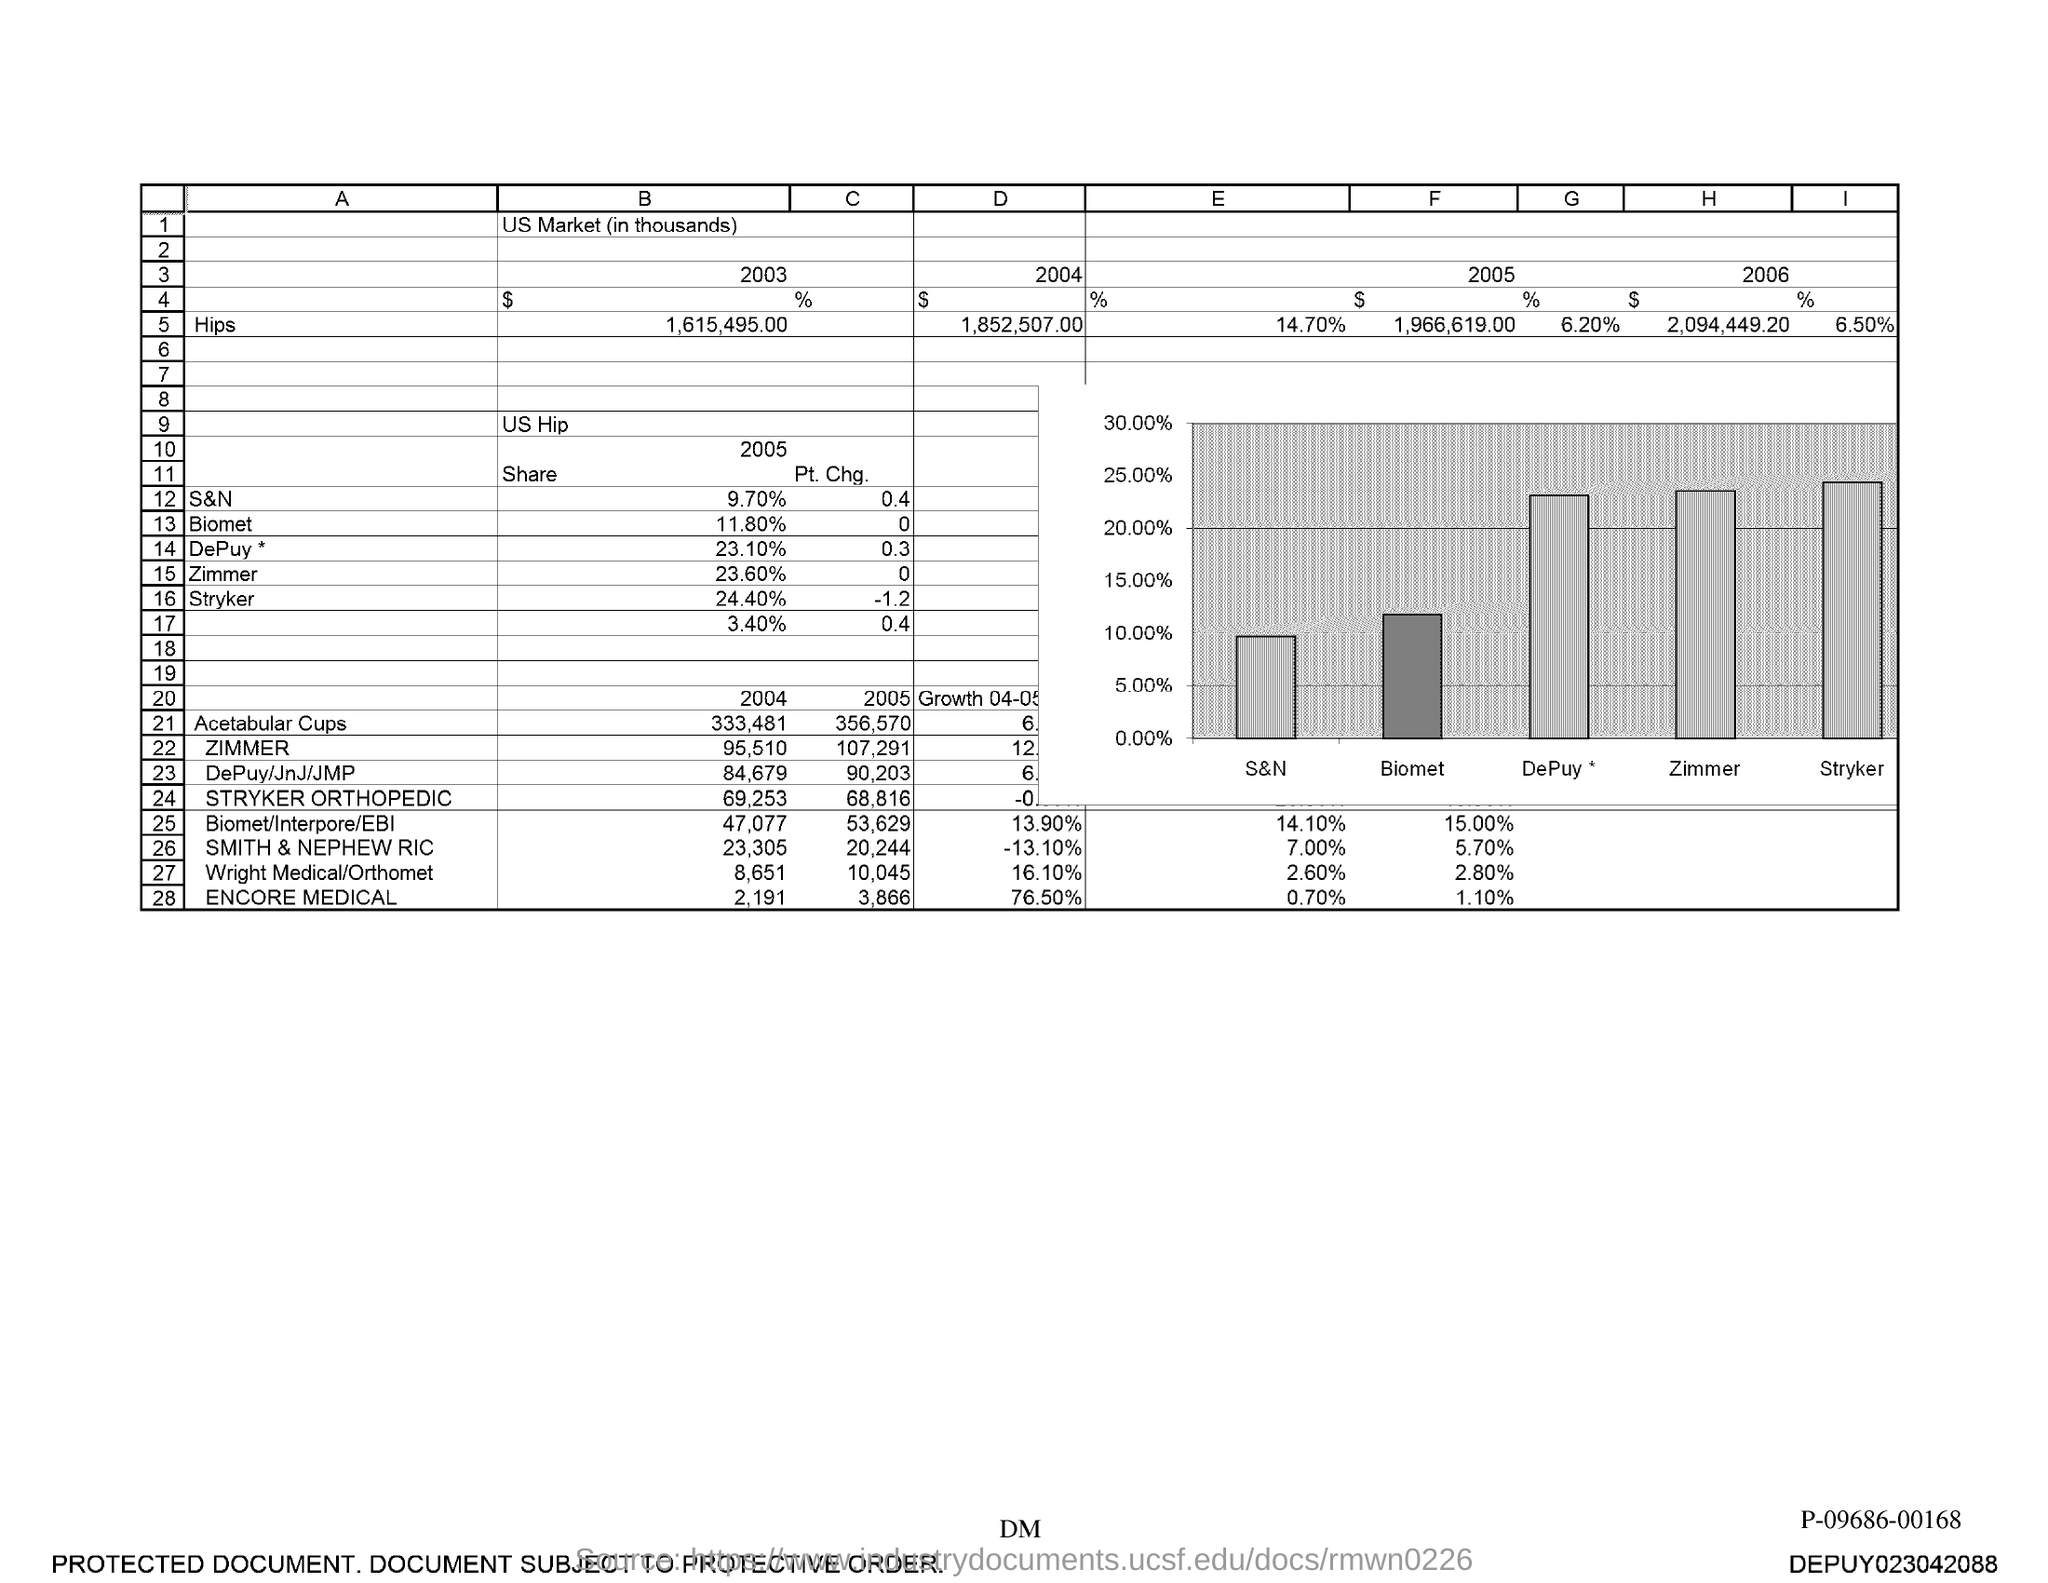What is the value of Hips in 2004?
Ensure brevity in your answer.  1,852,507. 